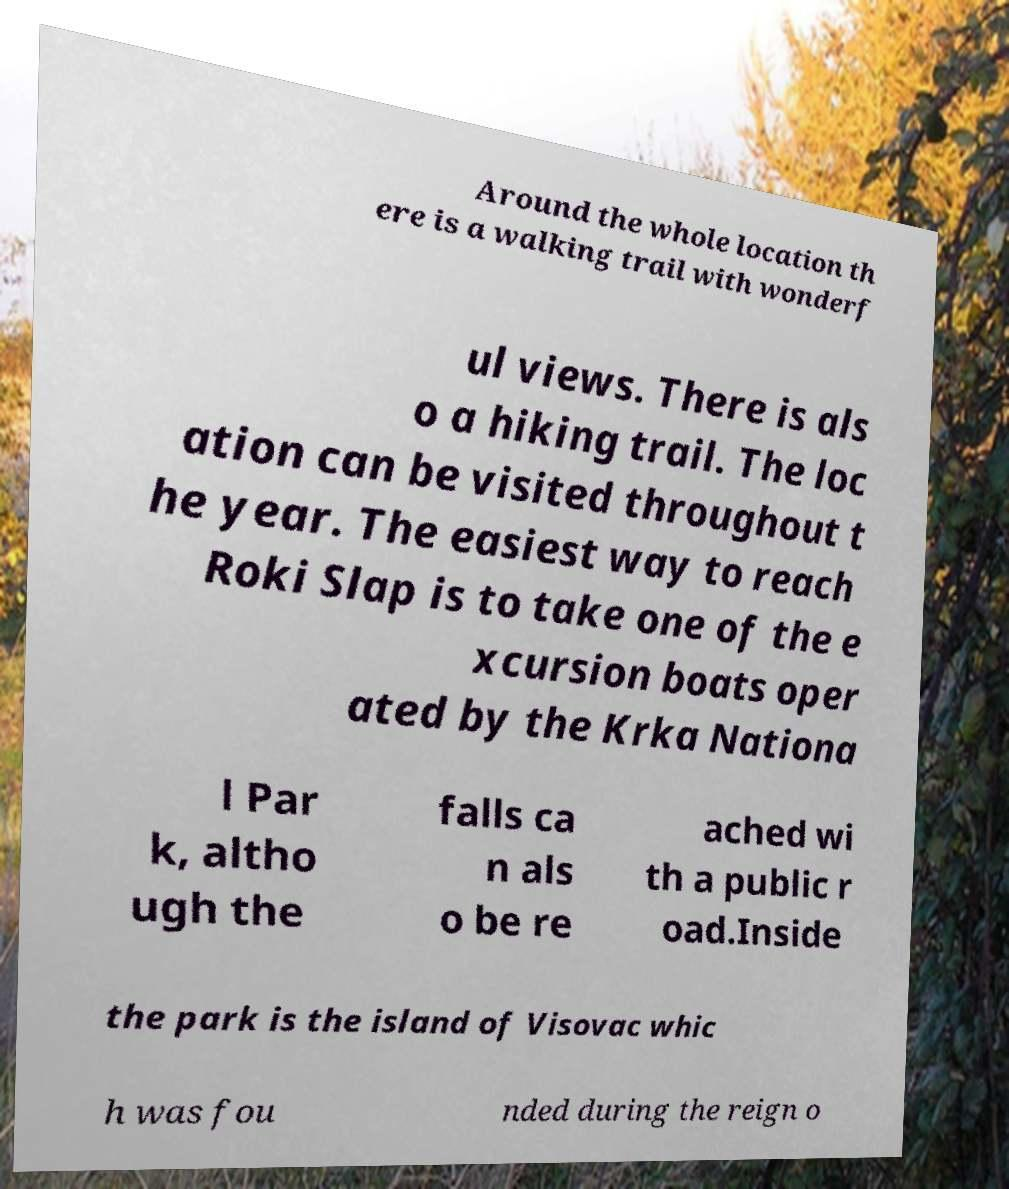Can you read and provide the text displayed in the image?This photo seems to have some interesting text. Can you extract and type it out for me? Around the whole location th ere is a walking trail with wonderf ul views. There is als o a hiking trail. The loc ation can be visited throughout t he year. The easiest way to reach Roki Slap is to take one of the e xcursion boats oper ated by the Krka Nationa l Par k, altho ugh the falls ca n als o be re ached wi th a public r oad.Inside the park is the island of Visovac whic h was fou nded during the reign o 